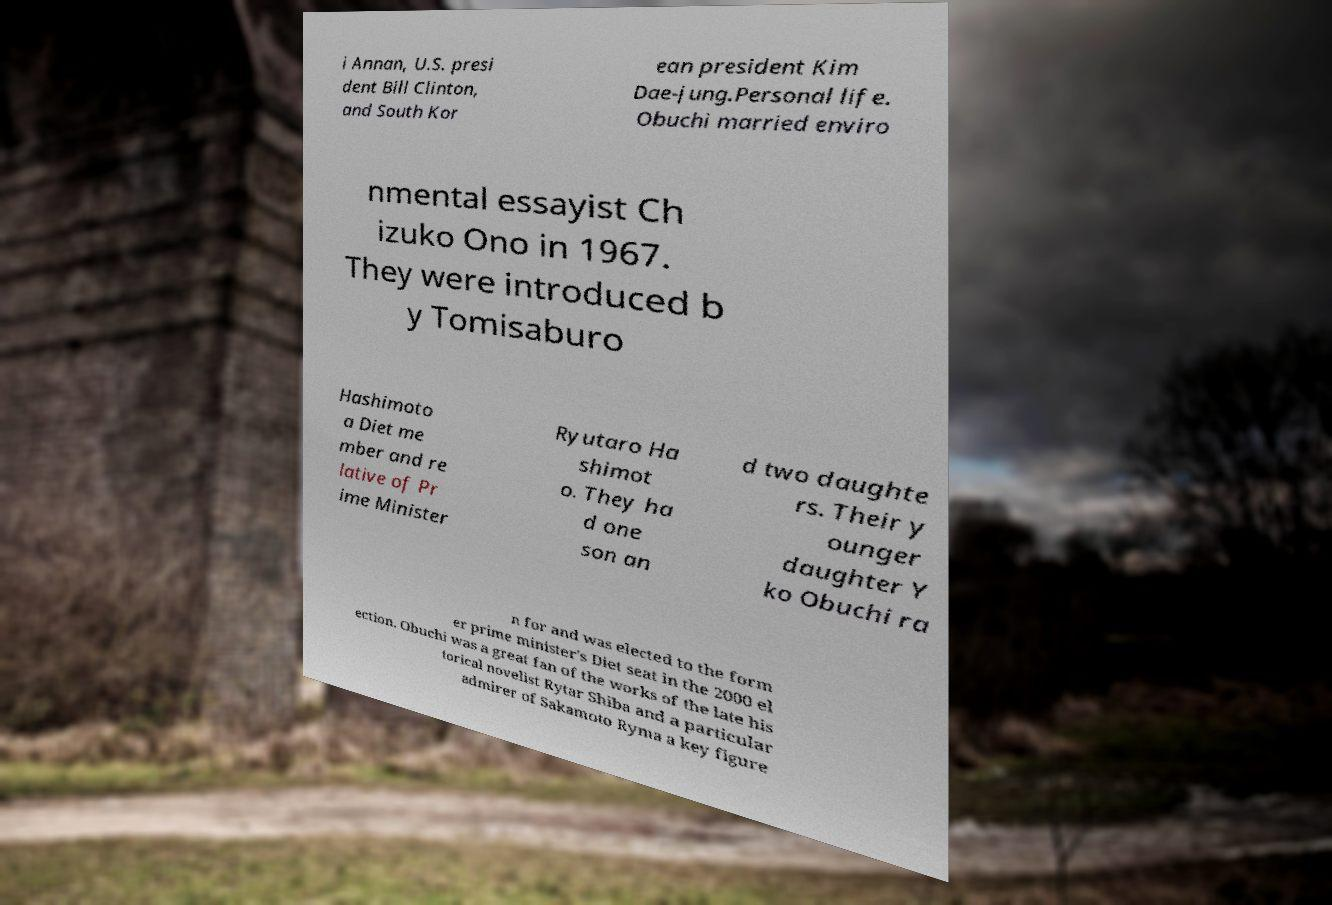What messages or text are displayed in this image? I need them in a readable, typed format. i Annan, U.S. presi dent Bill Clinton, and South Kor ean president Kim Dae-jung.Personal life. Obuchi married enviro nmental essayist Ch izuko Ono in 1967. They were introduced b y Tomisaburo Hashimoto a Diet me mber and re lative of Pr ime Minister Ryutaro Ha shimot o. They ha d one son an d two daughte rs. Their y ounger daughter Y ko Obuchi ra n for and was elected to the form er prime minister's Diet seat in the 2000 el ection. Obuchi was a great fan of the works of the late his torical novelist Rytar Shiba and a particular admirer of Sakamoto Ryma a key figure 